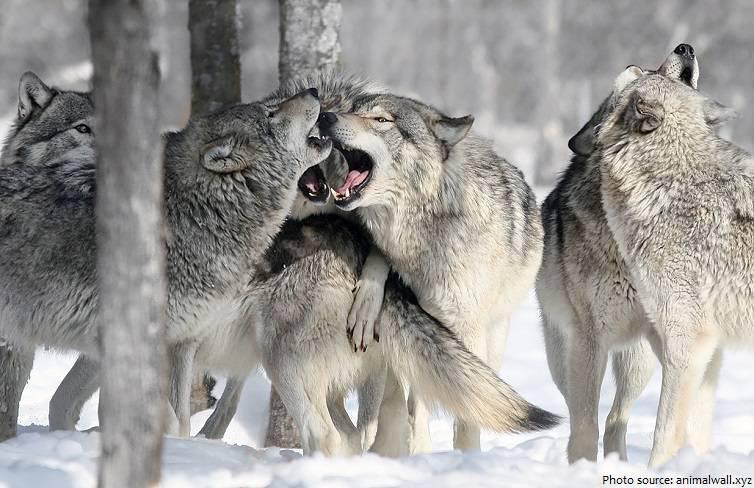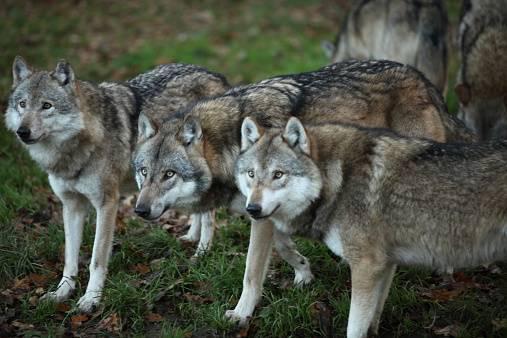The first image is the image on the left, the second image is the image on the right. Assess this claim about the two images: "In only one of the two images do all the animals appear to be focused on the same thing.". Correct or not? Answer yes or no. Yes. The first image is the image on the left, the second image is the image on the right. Given the left and right images, does the statement "The wolves are in the snow in only one of the images." hold true? Answer yes or no. Yes. 